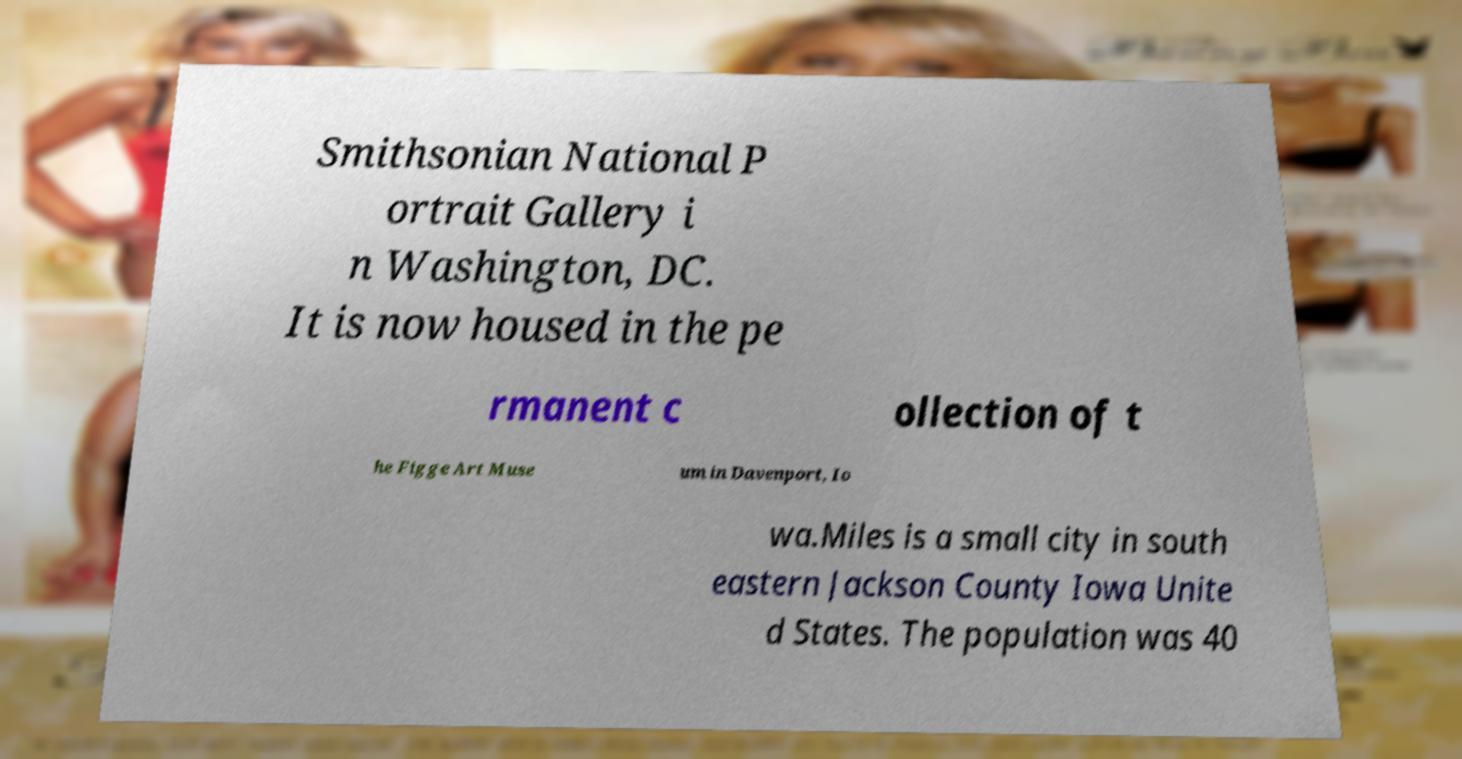Could you assist in decoding the text presented in this image and type it out clearly? Smithsonian National P ortrait Gallery i n Washington, DC. It is now housed in the pe rmanent c ollection of t he Figge Art Muse um in Davenport, Io wa.Miles is a small city in south eastern Jackson County Iowa Unite d States. The population was 40 